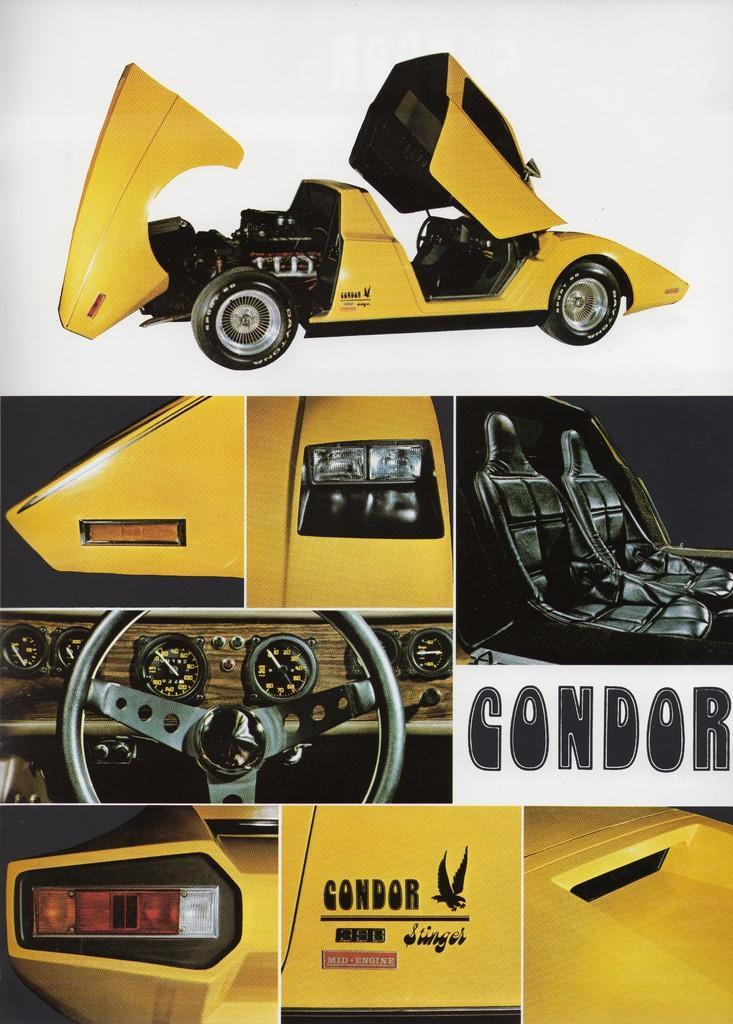In one or two sentences, can you explain what this image depicts? The picture is a collage of images. In this picture we can see the various parts of a car. At the top it is car. 